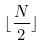<formula> <loc_0><loc_0><loc_500><loc_500>\lfloor \frac { N } { 2 } \rfloor</formula> 